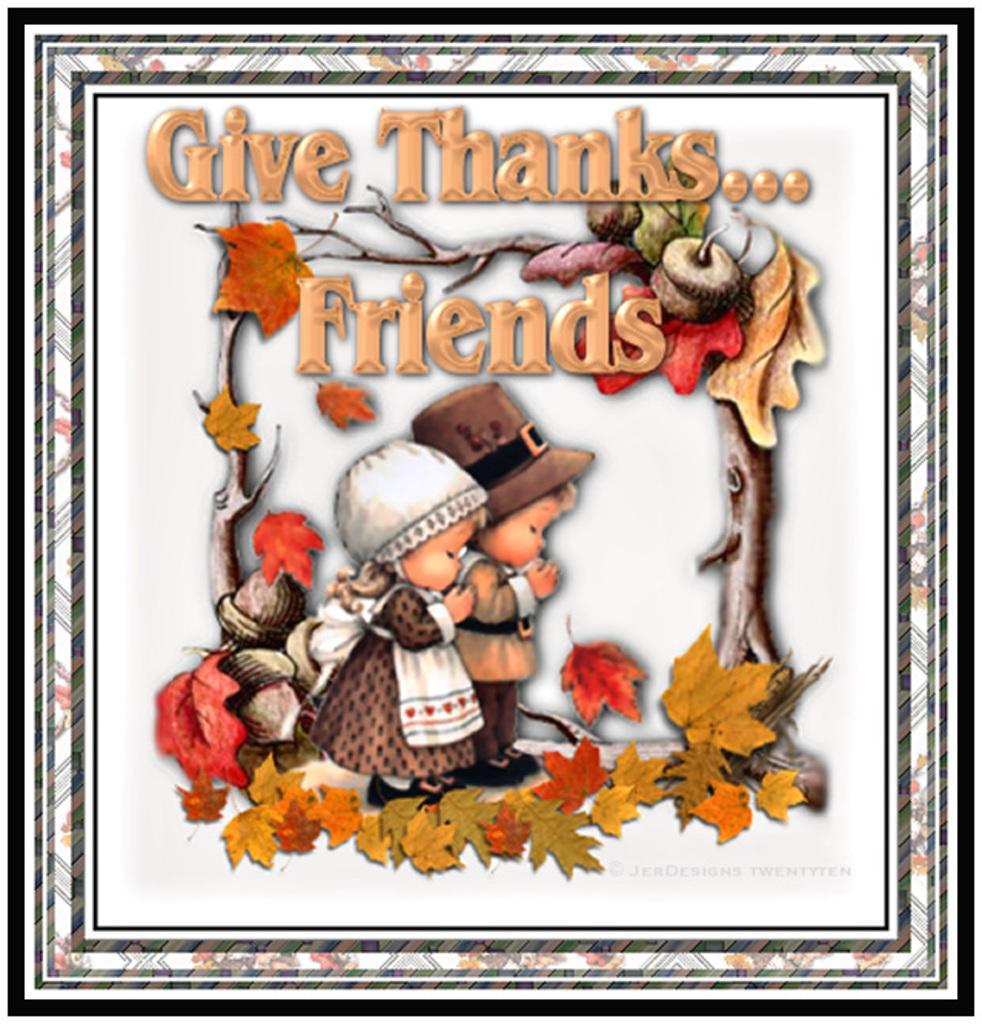In one or two sentences, can you explain what this image depicts? In the image there is a frame with painting in it. In that painting there are two persons, leaves, branches and fruits. And also there is text on it. 